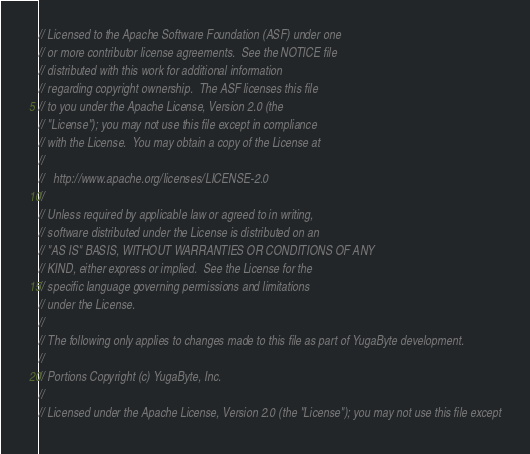Convert code to text. <code><loc_0><loc_0><loc_500><loc_500><_C++_>// Licensed to the Apache Software Foundation (ASF) under one
// or more contributor license agreements.  See the NOTICE file
// distributed with this work for additional information
// regarding copyright ownership.  The ASF licenses this file
// to you under the Apache License, Version 2.0 (the
// "License"); you may not use this file except in compliance
// with the License.  You may obtain a copy of the License at
//
//   http://www.apache.org/licenses/LICENSE-2.0
//
// Unless required by applicable law or agreed to in writing,
// software distributed under the License is distributed on an
// "AS IS" BASIS, WITHOUT WARRANTIES OR CONDITIONS OF ANY
// KIND, either express or implied.  See the License for the
// specific language governing permissions and limitations
// under the License.
//
// The following only applies to changes made to this file as part of YugaByte development.
//
// Portions Copyright (c) YugaByte, Inc.
//
// Licensed under the Apache License, Version 2.0 (the "License"); you may not use this file except</code> 